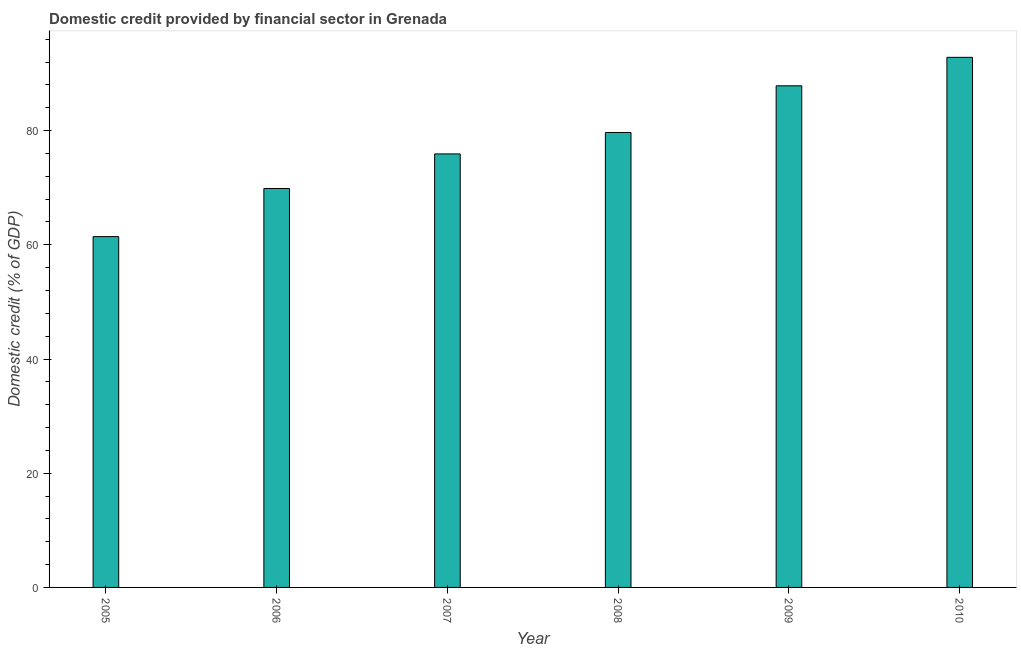What is the title of the graph?
Keep it short and to the point. Domestic credit provided by financial sector in Grenada. What is the label or title of the X-axis?
Give a very brief answer. Year. What is the label or title of the Y-axis?
Offer a very short reply. Domestic credit (% of GDP). What is the domestic credit provided by financial sector in 2006?
Ensure brevity in your answer.  69.86. Across all years, what is the maximum domestic credit provided by financial sector?
Provide a short and direct response. 92.83. Across all years, what is the minimum domestic credit provided by financial sector?
Your response must be concise. 61.43. In which year was the domestic credit provided by financial sector maximum?
Offer a very short reply. 2010. What is the sum of the domestic credit provided by financial sector?
Offer a terse response. 467.53. What is the difference between the domestic credit provided by financial sector in 2008 and 2010?
Your answer should be compact. -13.16. What is the average domestic credit provided by financial sector per year?
Provide a succinct answer. 77.92. What is the median domestic credit provided by financial sector?
Keep it short and to the point. 77.79. What is the ratio of the domestic credit provided by financial sector in 2006 to that in 2010?
Ensure brevity in your answer.  0.75. Is the domestic credit provided by financial sector in 2007 less than that in 2008?
Make the answer very short. Yes. What is the difference between the highest and the second highest domestic credit provided by financial sector?
Your response must be concise. 4.99. Is the sum of the domestic credit provided by financial sector in 2006 and 2010 greater than the maximum domestic credit provided by financial sector across all years?
Give a very brief answer. Yes. What is the difference between the highest and the lowest domestic credit provided by financial sector?
Ensure brevity in your answer.  31.4. In how many years, is the domestic credit provided by financial sector greater than the average domestic credit provided by financial sector taken over all years?
Give a very brief answer. 3. How many bars are there?
Offer a terse response. 6. How many years are there in the graph?
Your response must be concise. 6. What is the Domestic credit (% of GDP) of 2005?
Ensure brevity in your answer.  61.43. What is the Domestic credit (% of GDP) of 2006?
Give a very brief answer. 69.86. What is the Domestic credit (% of GDP) of 2007?
Your answer should be compact. 75.91. What is the Domestic credit (% of GDP) in 2008?
Your answer should be compact. 79.66. What is the Domestic credit (% of GDP) in 2009?
Provide a succinct answer. 87.84. What is the Domestic credit (% of GDP) in 2010?
Provide a succinct answer. 92.83. What is the difference between the Domestic credit (% of GDP) in 2005 and 2006?
Give a very brief answer. -8.43. What is the difference between the Domestic credit (% of GDP) in 2005 and 2007?
Your answer should be compact. -14.48. What is the difference between the Domestic credit (% of GDP) in 2005 and 2008?
Give a very brief answer. -18.23. What is the difference between the Domestic credit (% of GDP) in 2005 and 2009?
Your answer should be compact. -26.41. What is the difference between the Domestic credit (% of GDP) in 2005 and 2010?
Provide a succinct answer. -31.4. What is the difference between the Domestic credit (% of GDP) in 2006 and 2007?
Provide a succinct answer. -6.06. What is the difference between the Domestic credit (% of GDP) in 2006 and 2008?
Ensure brevity in your answer.  -9.81. What is the difference between the Domestic credit (% of GDP) in 2006 and 2009?
Ensure brevity in your answer.  -17.98. What is the difference between the Domestic credit (% of GDP) in 2006 and 2010?
Give a very brief answer. -22.97. What is the difference between the Domestic credit (% of GDP) in 2007 and 2008?
Provide a short and direct response. -3.75. What is the difference between the Domestic credit (% of GDP) in 2007 and 2009?
Ensure brevity in your answer.  -11.93. What is the difference between the Domestic credit (% of GDP) in 2007 and 2010?
Your answer should be very brief. -16.91. What is the difference between the Domestic credit (% of GDP) in 2008 and 2009?
Offer a terse response. -8.18. What is the difference between the Domestic credit (% of GDP) in 2008 and 2010?
Offer a very short reply. -13.16. What is the difference between the Domestic credit (% of GDP) in 2009 and 2010?
Provide a succinct answer. -4.99. What is the ratio of the Domestic credit (% of GDP) in 2005 to that in 2006?
Ensure brevity in your answer.  0.88. What is the ratio of the Domestic credit (% of GDP) in 2005 to that in 2007?
Your answer should be compact. 0.81. What is the ratio of the Domestic credit (% of GDP) in 2005 to that in 2008?
Ensure brevity in your answer.  0.77. What is the ratio of the Domestic credit (% of GDP) in 2005 to that in 2009?
Your response must be concise. 0.7. What is the ratio of the Domestic credit (% of GDP) in 2005 to that in 2010?
Ensure brevity in your answer.  0.66. What is the ratio of the Domestic credit (% of GDP) in 2006 to that in 2007?
Your answer should be compact. 0.92. What is the ratio of the Domestic credit (% of GDP) in 2006 to that in 2008?
Ensure brevity in your answer.  0.88. What is the ratio of the Domestic credit (% of GDP) in 2006 to that in 2009?
Provide a succinct answer. 0.8. What is the ratio of the Domestic credit (% of GDP) in 2006 to that in 2010?
Keep it short and to the point. 0.75. What is the ratio of the Domestic credit (% of GDP) in 2007 to that in 2008?
Offer a very short reply. 0.95. What is the ratio of the Domestic credit (% of GDP) in 2007 to that in 2009?
Your response must be concise. 0.86. What is the ratio of the Domestic credit (% of GDP) in 2007 to that in 2010?
Provide a succinct answer. 0.82. What is the ratio of the Domestic credit (% of GDP) in 2008 to that in 2009?
Offer a terse response. 0.91. What is the ratio of the Domestic credit (% of GDP) in 2008 to that in 2010?
Your response must be concise. 0.86. What is the ratio of the Domestic credit (% of GDP) in 2009 to that in 2010?
Provide a short and direct response. 0.95. 